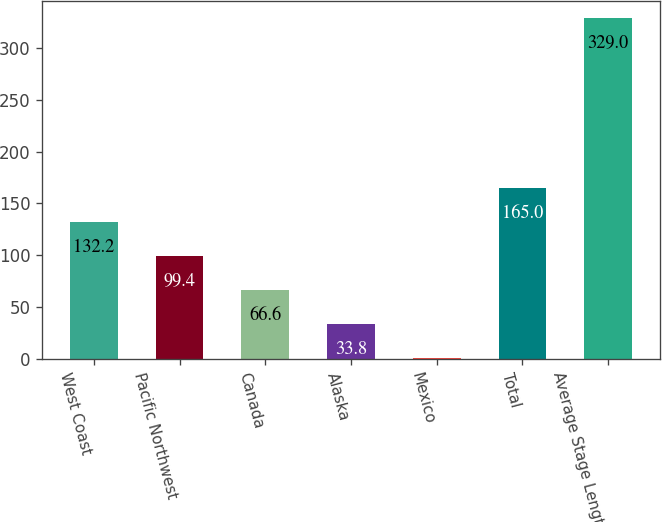Convert chart to OTSL. <chart><loc_0><loc_0><loc_500><loc_500><bar_chart><fcel>West Coast<fcel>Pacific Northwest<fcel>Canada<fcel>Alaska<fcel>Mexico<fcel>Total<fcel>Average Stage Length<nl><fcel>132.2<fcel>99.4<fcel>66.6<fcel>33.8<fcel>1<fcel>165<fcel>329<nl></chart> 